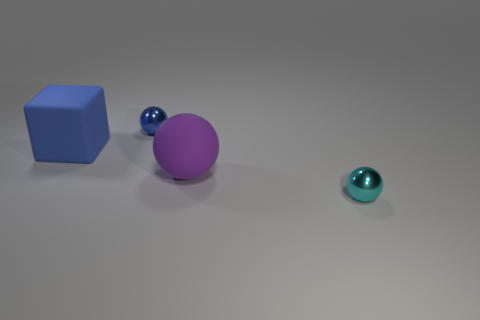How many objects are tiny cyan spheres or small things that are in front of the blue metal object?
Offer a very short reply. 1. Does the blue object that is in front of the tiny blue sphere have the same material as the large purple ball?
Provide a short and direct response. Yes. Is there anything else that has the same size as the cyan metal thing?
Ensure brevity in your answer.  Yes. What material is the large thing that is on the right side of the metallic thing that is behind the small cyan metallic thing made of?
Offer a terse response. Rubber. Is the number of big spheres that are on the right side of the cyan shiny sphere greater than the number of tiny metal things to the left of the rubber sphere?
Provide a succinct answer. No. What is the size of the rubber ball?
Provide a succinct answer. Large. There is a tiny object in front of the purple rubber thing; is its color the same as the big matte cube?
Ensure brevity in your answer.  No. Is there any other thing that has the same shape as the large purple rubber thing?
Provide a short and direct response. Yes. Are there any big objects in front of the metallic thing in front of the large blue block?
Ensure brevity in your answer.  No. Are there fewer tiny spheres that are behind the matte ball than tiny cyan balls in front of the blue block?
Offer a very short reply. No. 